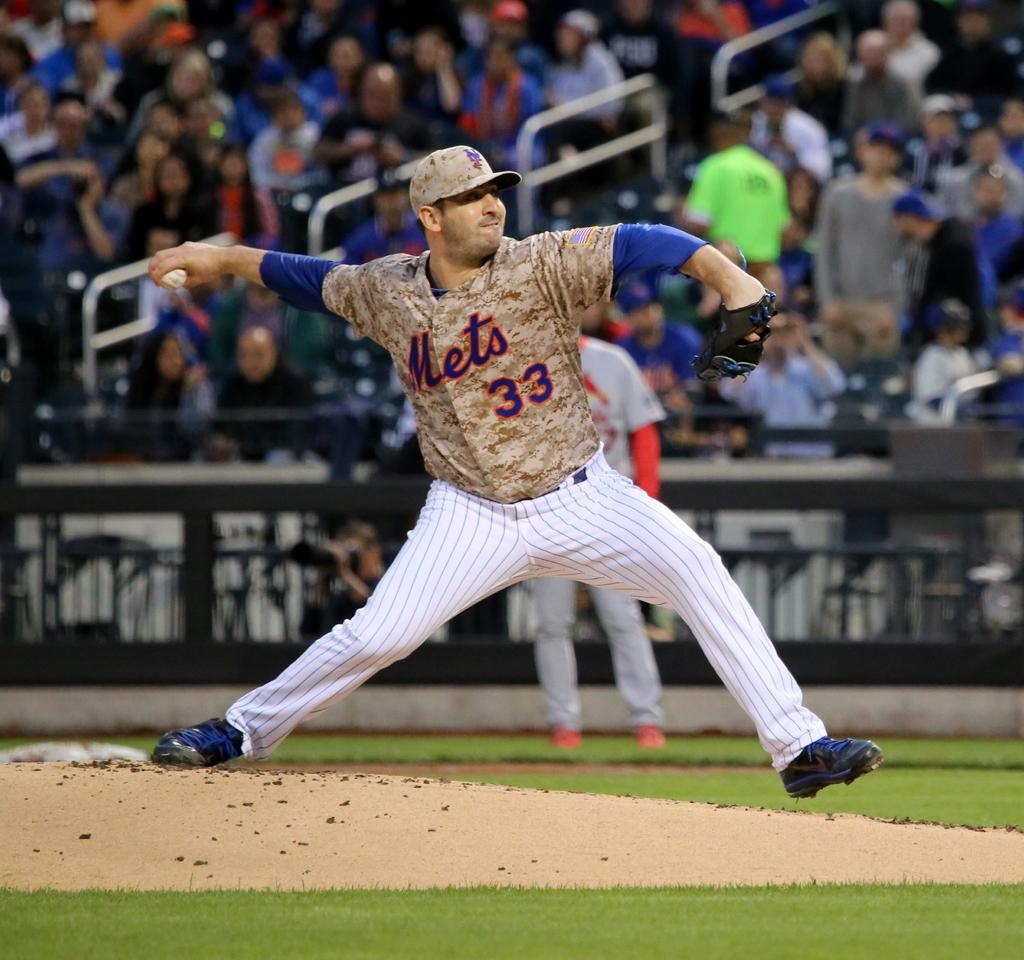Provide a one-sentence caption for the provided image. Number 33, Mets is the designation of the player on the mound. 